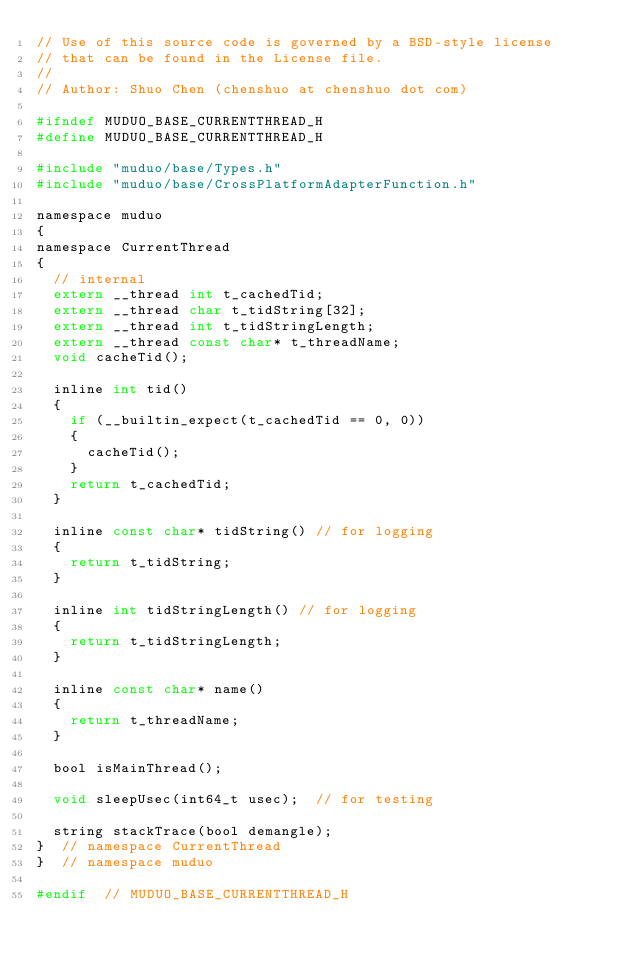<code> <loc_0><loc_0><loc_500><loc_500><_C_>// Use of this source code is governed by a BSD-style license
// that can be found in the License file.
//
// Author: Shuo Chen (chenshuo at chenshuo dot com)

#ifndef MUDUO_BASE_CURRENTTHREAD_H
#define MUDUO_BASE_CURRENTTHREAD_H

#include "muduo/base/Types.h"
#include "muduo/base/CrossPlatformAdapterFunction.h"

namespace muduo
{
namespace CurrentThread
{
  // internal
  extern __thread int t_cachedTid;
  extern __thread char t_tidString[32];
  extern __thread int t_tidStringLength;
  extern __thread const char* t_threadName;
  void cacheTid();

  inline int tid()
  {
    if (__builtin_expect(t_cachedTid == 0, 0))
    {
      cacheTid();
    }
    return t_cachedTid;
  }

  inline const char* tidString() // for logging
  {
    return t_tidString;
  }

  inline int tidStringLength() // for logging
  {
    return t_tidStringLength;
  }

  inline const char* name()
  {
    return t_threadName;
  }

  bool isMainThread();

  void sleepUsec(int64_t usec);  // for testing

  string stackTrace(bool demangle);
}  // namespace CurrentThread
}  // namespace muduo

#endif  // MUDUO_BASE_CURRENTTHREAD_H
</code> 